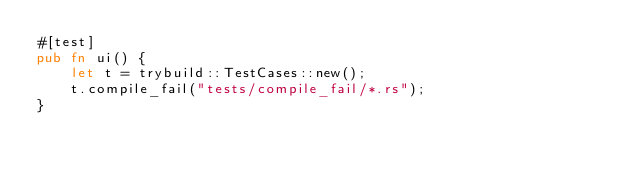<code> <loc_0><loc_0><loc_500><loc_500><_Rust_>#[test]
pub fn ui() {
    let t = trybuild::TestCases::new();
    t.compile_fail("tests/compile_fail/*.rs");
}
</code> 